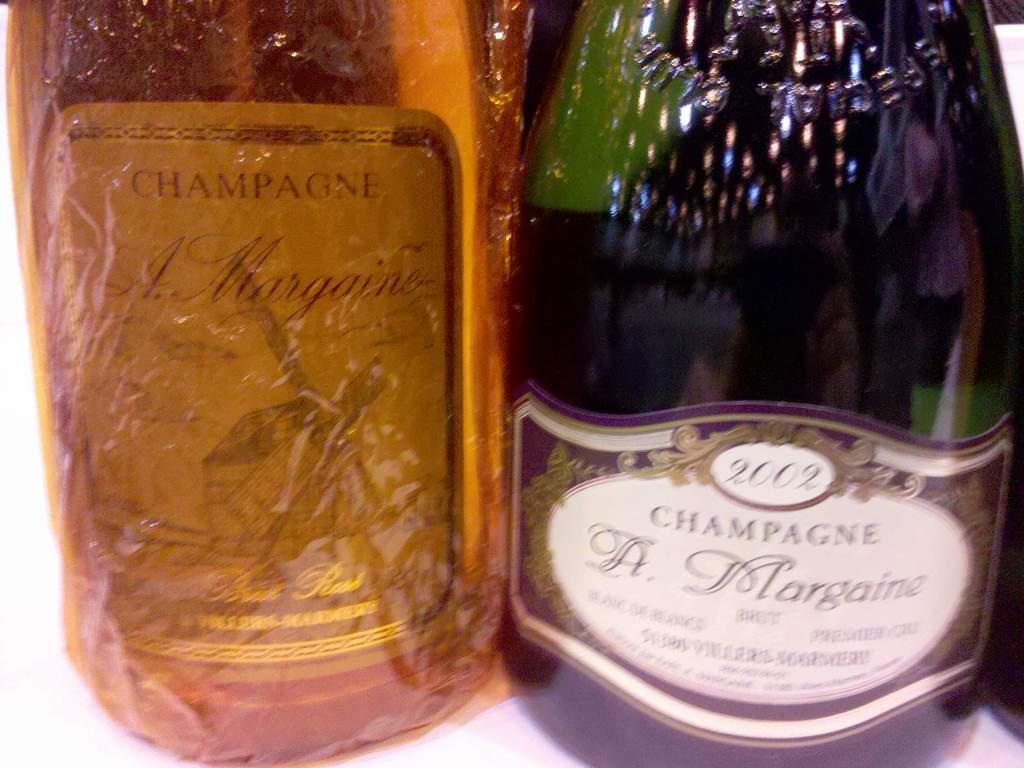What brand is this?
Offer a terse response. A margaine. What type sparkling wine is this? it is printed above the name "a. margaine" on the label?
Your answer should be very brief. Champagne. 